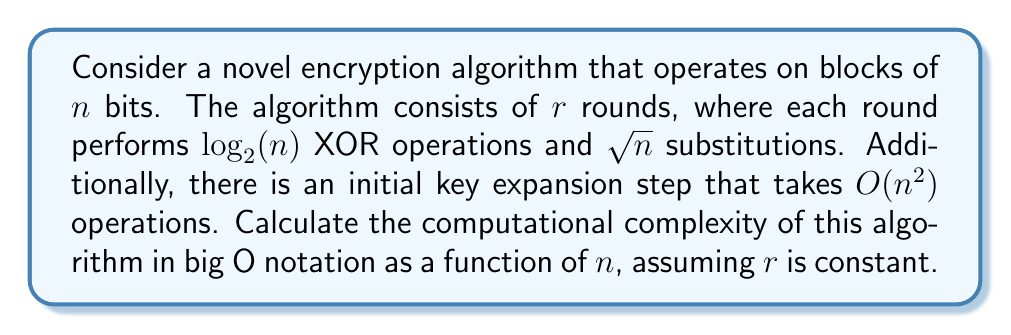Can you answer this question? Let's break down the algorithm and analyze its components:

1. Initial key expansion:
   - This step takes $O(n^2)$ operations.

2. Encryption rounds:
   - Number of rounds: $r$ (constant)
   - Each round consists of:
     a) $\log_2(n)$ XOR operations
     b) $\sqrt{n}$ substitutions

   - Total operations per round: $\log_2(n) + \sqrt{n}$
   - Since $\sqrt{n}$ grows faster than $\log_2(n)$, we can simplify this to $O(\sqrt{n})$

3. Total computational complexity:
   - Key expansion: $O(n^2)$
   - Encryption rounds: $r \cdot O(\sqrt{n}) = O(\sqrt{n})$ (since $r$ is constant)

4. Combining the complexities:
   $O(n^2) + O(\sqrt{n})$

5. The dominant term is $O(n^2)$, so we can simplify the final complexity to:
   $O(n^2)$

Therefore, the computational complexity of the algorithm is $O(n^2)$.
Answer: $O(n^2)$ 